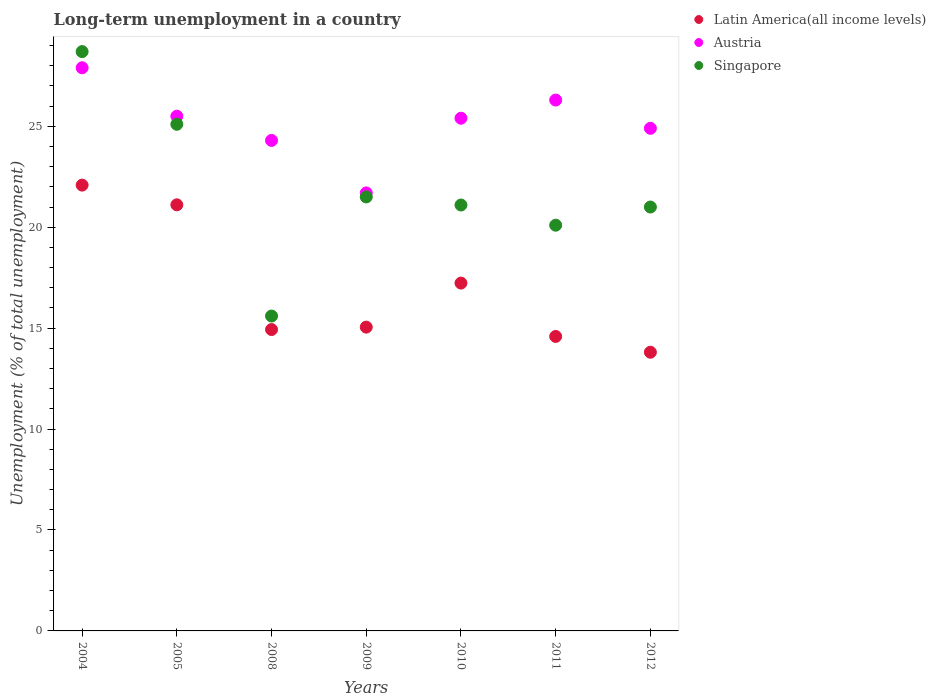How many different coloured dotlines are there?
Ensure brevity in your answer.  3. What is the percentage of long-term unemployed population in Latin America(all income levels) in 2008?
Your answer should be compact. 14.93. Across all years, what is the maximum percentage of long-term unemployed population in Austria?
Give a very brief answer. 27.9. Across all years, what is the minimum percentage of long-term unemployed population in Latin America(all income levels)?
Your response must be concise. 13.81. In which year was the percentage of long-term unemployed population in Singapore maximum?
Provide a short and direct response. 2004. In which year was the percentage of long-term unemployed population in Singapore minimum?
Your answer should be very brief. 2008. What is the total percentage of long-term unemployed population in Austria in the graph?
Your answer should be compact. 176. What is the difference between the percentage of long-term unemployed population in Singapore in 2005 and that in 2010?
Offer a terse response. 4. What is the difference between the percentage of long-term unemployed population in Singapore in 2005 and the percentage of long-term unemployed population in Latin America(all income levels) in 2010?
Give a very brief answer. 7.87. What is the average percentage of long-term unemployed population in Austria per year?
Your answer should be compact. 25.14. In the year 2012, what is the difference between the percentage of long-term unemployed population in Austria and percentage of long-term unemployed population in Singapore?
Your answer should be compact. 3.9. What is the ratio of the percentage of long-term unemployed population in Latin America(all income levels) in 2005 to that in 2008?
Your answer should be very brief. 1.41. Is the percentage of long-term unemployed population in Singapore in 2008 less than that in 2009?
Give a very brief answer. Yes. Is the difference between the percentage of long-term unemployed population in Austria in 2008 and 2010 greater than the difference between the percentage of long-term unemployed population in Singapore in 2008 and 2010?
Provide a succinct answer. Yes. What is the difference between the highest and the second highest percentage of long-term unemployed population in Latin America(all income levels)?
Provide a succinct answer. 0.98. What is the difference between the highest and the lowest percentage of long-term unemployed population in Austria?
Give a very brief answer. 6.2. Is the sum of the percentage of long-term unemployed population in Singapore in 2005 and 2012 greater than the maximum percentage of long-term unemployed population in Austria across all years?
Offer a very short reply. Yes. Is it the case that in every year, the sum of the percentage of long-term unemployed population in Singapore and percentage of long-term unemployed population in Austria  is greater than the percentage of long-term unemployed population in Latin America(all income levels)?
Your response must be concise. Yes. Does the percentage of long-term unemployed population in Latin America(all income levels) monotonically increase over the years?
Your response must be concise. No. How many dotlines are there?
Your answer should be very brief. 3. How many years are there in the graph?
Ensure brevity in your answer.  7. Are the values on the major ticks of Y-axis written in scientific E-notation?
Keep it short and to the point. No. Does the graph contain any zero values?
Offer a terse response. No. Where does the legend appear in the graph?
Your response must be concise. Top right. What is the title of the graph?
Make the answer very short. Long-term unemployment in a country. Does "Oman" appear as one of the legend labels in the graph?
Your response must be concise. No. What is the label or title of the Y-axis?
Keep it short and to the point. Unemployment (% of total unemployment). What is the Unemployment (% of total unemployment) in Latin America(all income levels) in 2004?
Provide a succinct answer. 22.09. What is the Unemployment (% of total unemployment) of Austria in 2004?
Your answer should be very brief. 27.9. What is the Unemployment (% of total unemployment) in Singapore in 2004?
Your answer should be very brief. 28.7. What is the Unemployment (% of total unemployment) of Latin America(all income levels) in 2005?
Your response must be concise. 21.11. What is the Unemployment (% of total unemployment) in Austria in 2005?
Ensure brevity in your answer.  25.5. What is the Unemployment (% of total unemployment) of Singapore in 2005?
Keep it short and to the point. 25.1. What is the Unemployment (% of total unemployment) of Latin America(all income levels) in 2008?
Make the answer very short. 14.93. What is the Unemployment (% of total unemployment) of Austria in 2008?
Give a very brief answer. 24.3. What is the Unemployment (% of total unemployment) of Singapore in 2008?
Your answer should be very brief. 15.6. What is the Unemployment (% of total unemployment) of Latin America(all income levels) in 2009?
Ensure brevity in your answer.  15.05. What is the Unemployment (% of total unemployment) in Austria in 2009?
Make the answer very short. 21.7. What is the Unemployment (% of total unemployment) in Singapore in 2009?
Provide a succinct answer. 21.5. What is the Unemployment (% of total unemployment) of Latin America(all income levels) in 2010?
Your response must be concise. 17.23. What is the Unemployment (% of total unemployment) in Austria in 2010?
Your response must be concise. 25.4. What is the Unemployment (% of total unemployment) in Singapore in 2010?
Your answer should be compact. 21.1. What is the Unemployment (% of total unemployment) of Latin America(all income levels) in 2011?
Keep it short and to the point. 14.59. What is the Unemployment (% of total unemployment) in Austria in 2011?
Provide a succinct answer. 26.3. What is the Unemployment (% of total unemployment) of Singapore in 2011?
Offer a very short reply. 20.1. What is the Unemployment (% of total unemployment) in Latin America(all income levels) in 2012?
Ensure brevity in your answer.  13.81. What is the Unemployment (% of total unemployment) in Austria in 2012?
Your answer should be very brief. 24.9. What is the Unemployment (% of total unemployment) of Singapore in 2012?
Offer a very short reply. 21. Across all years, what is the maximum Unemployment (% of total unemployment) of Latin America(all income levels)?
Keep it short and to the point. 22.09. Across all years, what is the maximum Unemployment (% of total unemployment) of Austria?
Ensure brevity in your answer.  27.9. Across all years, what is the maximum Unemployment (% of total unemployment) in Singapore?
Offer a very short reply. 28.7. Across all years, what is the minimum Unemployment (% of total unemployment) of Latin America(all income levels)?
Your answer should be compact. 13.81. Across all years, what is the minimum Unemployment (% of total unemployment) in Austria?
Offer a terse response. 21.7. Across all years, what is the minimum Unemployment (% of total unemployment) of Singapore?
Ensure brevity in your answer.  15.6. What is the total Unemployment (% of total unemployment) of Latin America(all income levels) in the graph?
Ensure brevity in your answer.  118.8. What is the total Unemployment (% of total unemployment) in Austria in the graph?
Offer a terse response. 176. What is the total Unemployment (% of total unemployment) in Singapore in the graph?
Give a very brief answer. 153.1. What is the difference between the Unemployment (% of total unemployment) of Latin America(all income levels) in 2004 and that in 2005?
Make the answer very short. 0.98. What is the difference between the Unemployment (% of total unemployment) of Austria in 2004 and that in 2005?
Provide a short and direct response. 2.4. What is the difference between the Unemployment (% of total unemployment) of Singapore in 2004 and that in 2005?
Give a very brief answer. 3.6. What is the difference between the Unemployment (% of total unemployment) in Latin America(all income levels) in 2004 and that in 2008?
Provide a succinct answer. 7.16. What is the difference between the Unemployment (% of total unemployment) in Latin America(all income levels) in 2004 and that in 2009?
Make the answer very short. 7.04. What is the difference between the Unemployment (% of total unemployment) in Austria in 2004 and that in 2009?
Your answer should be compact. 6.2. What is the difference between the Unemployment (% of total unemployment) in Singapore in 2004 and that in 2009?
Ensure brevity in your answer.  7.2. What is the difference between the Unemployment (% of total unemployment) in Latin America(all income levels) in 2004 and that in 2010?
Ensure brevity in your answer.  4.85. What is the difference between the Unemployment (% of total unemployment) of Austria in 2004 and that in 2010?
Your answer should be compact. 2.5. What is the difference between the Unemployment (% of total unemployment) of Singapore in 2004 and that in 2010?
Ensure brevity in your answer.  7.6. What is the difference between the Unemployment (% of total unemployment) in Latin America(all income levels) in 2004 and that in 2011?
Offer a very short reply. 7.5. What is the difference between the Unemployment (% of total unemployment) of Latin America(all income levels) in 2004 and that in 2012?
Offer a terse response. 8.28. What is the difference between the Unemployment (% of total unemployment) of Singapore in 2004 and that in 2012?
Make the answer very short. 7.7. What is the difference between the Unemployment (% of total unemployment) of Latin America(all income levels) in 2005 and that in 2008?
Your response must be concise. 6.18. What is the difference between the Unemployment (% of total unemployment) in Austria in 2005 and that in 2008?
Your answer should be very brief. 1.2. What is the difference between the Unemployment (% of total unemployment) in Latin America(all income levels) in 2005 and that in 2009?
Make the answer very short. 6.06. What is the difference between the Unemployment (% of total unemployment) in Singapore in 2005 and that in 2009?
Your response must be concise. 3.6. What is the difference between the Unemployment (% of total unemployment) in Latin America(all income levels) in 2005 and that in 2010?
Your answer should be compact. 3.88. What is the difference between the Unemployment (% of total unemployment) of Singapore in 2005 and that in 2010?
Your response must be concise. 4. What is the difference between the Unemployment (% of total unemployment) in Latin America(all income levels) in 2005 and that in 2011?
Make the answer very short. 6.52. What is the difference between the Unemployment (% of total unemployment) of Austria in 2005 and that in 2011?
Your answer should be compact. -0.8. What is the difference between the Unemployment (% of total unemployment) in Latin America(all income levels) in 2005 and that in 2012?
Your answer should be compact. 7.3. What is the difference between the Unemployment (% of total unemployment) in Austria in 2005 and that in 2012?
Your answer should be compact. 0.6. What is the difference between the Unemployment (% of total unemployment) in Singapore in 2005 and that in 2012?
Provide a succinct answer. 4.1. What is the difference between the Unemployment (% of total unemployment) of Latin America(all income levels) in 2008 and that in 2009?
Keep it short and to the point. -0.12. What is the difference between the Unemployment (% of total unemployment) in Singapore in 2008 and that in 2009?
Make the answer very short. -5.9. What is the difference between the Unemployment (% of total unemployment) in Latin America(all income levels) in 2008 and that in 2010?
Provide a short and direct response. -2.3. What is the difference between the Unemployment (% of total unemployment) of Austria in 2008 and that in 2010?
Your response must be concise. -1.1. What is the difference between the Unemployment (% of total unemployment) of Latin America(all income levels) in 2008 and that in 2011?
Your answer should be compact. 0.34. What is the difference between the Unemployment (% of total unemployment) in Austria in 2008 and that in 2011?
Provide a short and direct response. -2. What is the difference between the Unemployment (% of total unemployment) in Latin America(all income levels) in 2008 and that in 2012?
Your answer should be compact. 1.12. What is the difference between the Unemployment (% of total unemployment) of Austria in 2008 and that in 2012?
Your response must be concise. -0.6. What is the difference between the Unemployment (% of total unemployment) of Singapore in 2008 and that in 2012?
Make the answer very short. -5.4. What is the difference between the Unemployment (% of total unemployment) in Latin America(all income levels) in 2009 and that in 2010?
Provide a short and direct response. -2.18. What is the difference between the Unemployment (% of total unemployment) of Austria in 2009 and that in 2010?
Ensure brevity in your answer.  -3.7. What is the difference between the Unemployment (% of total unemployment) of Latin America(all income levels) in 2009 and that in 2011?
Ensure brevity in your answer.  0.46. What is the difference between the Unemployment (% of total unemployment) of Latin America(all income levels) in 2009 and that in 2012?
Give a very brief answer. 1.24. What is the difference between the Unemployment (% of total unemployment) in Singapore in 2009 and that in 2012?
Your answer should be very brief. 0.5. What is the difference between the Unemployment (% of total unemployment) of Latin America(all income levels) in 2010 and that in 2011?
Give a very brief answer. 2.64. What is the difference between the Unemployment (% of total unemployment) in Singapore in 2010 and that in 2011?
Offer a terse response. 1. What is the difference between the Unemployment (% of total unemployment) in Latin America(all income levels) in 2010 and that in 2012?
Make the answer very short. 3.43. What is the difference between the Unemployment (% of total unemployment) in Latin America(all income levels) in 2011 and that in 2012?
Keep it short and to the point. 0.78. What is the difference between the Unemployment (% of total unemployment) of Latin America(all income levels) in 2004 and the Unemployment (% of total unemployment) of Austria in 2005?
Offer a terse response. -3.41. What is the difference between the Unemployment (% of total unemployment) of Latin America(all income levels) in 2004 and the Unemployment (% of total unemployment) of Singapore in 2005?
Keep it short and to the point. -3.01. What is the difference between the Unemployment (% of total unemployment) in Austria in 2004 and the Unemployment (% of total unemployment) in Singapore in 2005?
Provide a short and direct response. 2.8. What is the difference between the Unemployment (% of total unemployment) in Latin America(all income levels) in 2004 and the Unemployment (% of total unemployment) in Austria in 2008?
Offer a terse response. -2.21. What is the difference between the Unemployment (% of total unemployment) of Latin America(all income levels) in 2004 and the Unemployment (% of total unemployment) of Singapore in 2008?
Offer a terse response. 6.49. What is the difference between the Unemployment (% of total unemployment) of Latin America(all income levels) in 2004 and the Unemployment (% of total unemployment) of Austria in 2009?
Your answer should be compact. 0.39. What is the difference between the Unemployment (% of total unemployment) of Latin America(all income levels) in 2004 and the Unemployment (% of total unemployment) of Singapore in 2009?
Your answer should be very brief. 0.59. What is the difference between the Unemployment (% of total unemployment) of Austria in 2004 and the Unemployment (% of total unemployment) of Singapore in 2009?
Your answer should be compact. 6.4. What is the difference between the Unemployment (% of total unemployment) of Latin America(all income levels) in 2004 and the Unemployment (% of total unemployment) of Austria in 2010?
Your answer should be compact. -3.31. What is the difference between the Unemployment (% of total unemployment) in Latin America(all income levels) in 2004 and the Unemployment (% of total unemployment) in Singapore in 2010?
Make the answer very short. 0.99. What is the difference between the Unemployment (% of total unemployment) in Austria in 2004 and the Unemployment (% of total unemployment) in Singapore in 2010?
Give a very brief answer. 6.8. What is the difference between the Unemployment (% of total unemployment) in Latin America(all income levels) in 2004 and the Unemployment (% of total unemployment) in Austria in 2011?
Ensure brevity in your answer.  -4.21. What is the difference between the Unemployment (% of total unemployment) of Latin America(all income levels) in 2004 and the Unemployment (% of total unemployment) of Singapore in 2011?
Your response must be concise. 1.99. What is the difference between the Unemployment (% of total unemployment) in Austria in 2004 and the Unemployment (% of total unemployment) in Singapore in 2011?
Offer a very short reply. 7.8. What is the difference between the Unemployment (% of total unemployment) in Latin America(all income levels) in 2004 and the Unemployment (% of total unemployment) in Austria in 2012?
Keep it short and to the point. -2.81. What is the difference between the Unemployment (% of total unemployment) in Latin America(all income levels) in 2004 and the Unemployment (% of total unemployment) in Singapore in 2012?
Keep it short and to the point. 1.09. What is the difference between the Unemployment (% of total unemployment) of Latin America(all income levels) in 2005 and the Unemployment (% of total unemployment) of Austria in 2008?
Keep it short and to the point. -3.19. What is the difference between the Unemployment (% of total unemployment) in Latin America(all income levels) in 2005 and the Unemployment (% of total unemployment) in Singapore in 2008?
Your response must be concise. 5.51. What is the difference between the Unemployment (% of total unemployment) in Latin America(all income levels) in 2005 and the Unemployment (% of total unemployment) in Austria in 2009?
Keep it short and to the point. -0.59. What is the difference between the Unemployment (% of total unemployment) in Latin America(all income levels) in 2005 and the Unemployment (% of total unemployment) in Singapore in 2009?
Provide a succinct answer. -0.39. What is the difference between the Unemployment (% of total unemployment) in Austria in 2005 and the Unemployment (% of total unemployment) in Singapore in 2009?
Give a very brief answer. 4. What is the difference between the Unemployment (% of total unemployment) in Latin America(all income levels) in 2005 and the Unemployment (% of total unemployment) in Austria in 2010?
Provide a succinct answer. -4.29. What is the difference between the Unemployment (% of total unemployment) in Latin America(all income levels) in 2005 and the Unemployment (% of total unemployment) in Singapore in 2010?
Keep it short and to the point. 0.01. What is the difference between the Unemployment (% of total unemployment) of Austria in 2005 and the Unemployment (% of total unemployment) of Singapore in 2010?
Your response must be concise. 4.4. What is the difference between the Unemployment (% of total unemployment) of Latin America(all income levels) in 2005 and the Unemployment (% of total unemployment) of Austria in 2011?
Give a very brief answer. -5.19. What is the difference between the Unemployment (% of total unemployment) in Latin America(all income levels) in 2005 and the Unemployment (% of total unemployment) in Singapore in 2011?
Offer a terse response. 1.01. What is the difference between the Unemployment (% of total unemployment) of Latin America(all income levels) in 2005 and the Unemployment (% of total unemployment) of Austria in 2012?
Your answer should be very brief. -3.79. What is the difference between the Unemployment (% of total unemployment) in Latin America(all income levels) in 2005 and the Unemployment (% of total unemployment) in Singapore in 2012?
Offer a very short reply. 0.11. What is the difference between the Unemployment (% of total unemployment) of Latin America(all income levels) in 2008 and the Unemployment (% of total unemployment) of Austria in 2009?
Your response must be concise. -6.77. What is the difference between the Unemployment (% of total unemployment) of Latin America(all income levels) in 2008 and the Unemployment (% of total unemployment) of Singapore in 2009?
Your response must be concise. -6.57. What is the difference between the Unemployment (% of total unemployment) in Latin America(all income levels) in 2008 and the Unemployment (% of total unemployment) in Austria in 2010?
Provide a short and direct response. -10.47. What is the difference between the Unemployment (% of total unemployment) in Latin America(all income levels) in 2008 and the Unemployment (% of total unemployment) in Singapore in 2010?
Make the answer very short. -6.17. What is the difference between the Unemployment (% of total unemployment) of Latin America(all income levels) in 2008 and the Unemployment (% of total unemployment) of Austria in 2011?
Offer a very short reply. -11.37. What is the difference between the Unemployment (% of total unemployment) in Latin America(all income levels) in 2008 and the Unemployment (% of total unemployment) in Singapore in 2011?
Keep it short and to the point. -5.17. What is the difference between the Unemployment (% of total unemployment) of Latin America(all income levels) in 2008 and the Unemployment (% of total unemployment) of Austria in 2012?
Your answer should be very brief. -9.97. What is the difference between the Unemployment (% of total unemployment) of Latin America(all income levels) in 2008 and the Unemployment (% of total unemployment) of Singapore in 2012?
Your response must be concise. -6.07. What is the difference between the Unemployment (% of total unemployment) of Austria in 2008 and the Unemployment (% of total unemployment) of Singapore in 2012?
Your response must be concise. 3.3. What is the difference between the Unemployment (% of total unemployment) in Latin America(all income levels) in 2009 and the Unemployment (% of total unemployment) in Austria in 2010?
Ensure brevity in your answer.  -10.35. What is the difference between the Unemployment (% of total unemployment) in Latin America(all income levels) in 2009 and the Unemployment (% of total unemployment) in Singapore in 2010?
Your answer should be very brief. -6.05. What is the difference between the Unemployment (% of total unemployment) of Latin America(all income levels) in 2009 and the Unemployment (% of total unemployment) of Austria in 2011?
Give a very brief answer. -11.25. What is the difference between the Unemployment (% of total unemployment) of Latin America(all income levels) in 2009 and the Unemployment (% of total unemployment) of Singapore in 2011?
Offer a very short reply. -5.05. What is the difference between the Unemployment (% of total unemployment) in Latin America(all income levels) in 2009 and the Unemployment (% of total unemployment) in Austria in 2012?
Offer a terse response. -9.85. What is the difference between the Unemployment (% of total unemployment) of Latin America(all income levels) in 2009 and the Unemployment (% of total unemployment) of Singapore in 2012?
Your response must be concise. -5.95. What is the difference between the Unemployment (% of total unemployment) in Latin America(all income levels) in 2010 and the Unemployment (% of total unemployment) in Austria in 2011?
Keep it short and to the point. -9.07. What is the difference between the Unemployment (% of total unemployment) in Latin America(all income levels) in 2010 and the Unemployment (% of total unemployment) in Singapore in 2011?
Offer a terse response. -2.87. What is the difference between the Unemployment (% of total unemployment) in Latin America(all income levels) in 2010 and the Unemployment (% of total unemployment) in Austria in 2012?
Provide a succinct answer. -7.67. What is the difference between the Unemployment (% of total unemployment) in Latin America(all income levels) in 2010 and the Unemployment (% of total unemployment) in Singapore in 2012?
Keep it short and to the point. -3.77. What is the difference between the Unemployment (% of total unemployment) in Austria in 2010 and the Unemployment (% of total unemployment) in Singapore in 2012?
Your answer should be compact. 4.4. What is the difference between the Unemployment (% of total unemployment) of Latin America(all income levels) in 2011 and the Unemployment (% of total unemployment) of Austria in 2012?
Your answer should be compact. -10.31. What is the difference between the Unemployment (% of total unemployment) of Latin America(all income levels) in 2011 and the Unemployment (% of total unemployment) of Singapore in 2012?
Your response must be concise. -6.41. What is the difference between the Unemployment (% of total unemployment) of Austria in 2011 and the Unemployment (% of total unemployment) of Singapore in 2012?
Offer a terse response. 5.3. What is the average Unemployment (% of total unemployment) of Latin America(all income levels) per year?
Keep it short and to the point. 16.97. What is the average Unemployment (% of total unemployment) of Austria per year?
Your response must be concise. 25.14. What is the average Unemployment (% of total unemployment) of Singapore per year?
Provide a short and direct response. 21.87. In the year 2004, what is the difference between the Unemployment (% of total unemployment) of Latin America(all income levels) and Unemployment (% of total unemployment) of Austria?
Provide a succinct answer. -5.81. In the year 2004, what is the difference between the Unemployment (% of total unemployment) of Latin America(all income levels) and Unemployment (% of total unemployment) of Singapore?
Offer a terse response. -6.61. In the year 2005, what is the difference between the Unemployment (% of total unemployment) of Latin America(all income levels) and Unemployment (% of total unemployment) of Austria?
Make the answer very short. -4.39. In the year 2005, what is the difference between the Unemployment (% of total unemployment) in Latin America(all income levels) and Unemployment (% of total unemployment) in Singapore?
Give a very brief answer. -3.99. In the year 2005, what is the difference between the Unemployment (% of total unemployment) in Austria and Unemployment (% of total unemployment) in Singapore?
Ensure brevity in your answer.  0.4. In the year 2008, what is the difference between the Unemployment (% of total unemployment) of Latin America(all income levels) and Unemployment (% of total unemployment) of Austria?
Provide a succinct answer. -9.37. In the year 2008, what is the difference between the Unemployment (% of total unemployment) of Latin America(all income levels) and Unemployment (% of total unemployment) of Singapore?
Keep it short and to the point. -0.67. In the year 2009, what is the difference between the Unemployment (% of total unemployment) in Latin America(all income levels) and Unemployment (% of total unemployment) in Austria?
Offer a very short reply. -6.65. In the year 2009, what is the difference between the Unemployment (% of total unemployment) of Latin America(all income levels) and Unemployment (% of total unemployment) of Singapore?
Provide a succinct answer. -6.45. In the year 2010, what is the difference between the Unemployment (% of total unemployment) in Latin America(all income levels) and Unemployment (% of total unemployment) in Austria?
Give a very brief answer. -8.17. In the year 2010, what is the difference between the Unemployment (% of total unemployment) of Latin America(all income levels) and Unemployment (% of total unemployment) of Singapore?
Offer a terse response. -3.87. In the year 2010, what is the difference between the Unemployment (% of total unemployment) of Austria and Unemployment (% of total unemployment) of Singapore?
Give a very brief answer. 4.3. In the year 2011, what is the difference between the Unemployment (% of total unemployment) in Latin America(all income levels) and Unemployment (% of total unemployment) in Austria?
Your answer should be very brief. -11.71. In the year 2011, what is the difference between the Unemployment (% of total unemployment) in Latin America(all income levels) and Unemployment (% of total unemployment) in Singapore?
Provide a succinct answer. -5.51. In the year 2011, what is the difference between the Unemployment (% of total unemployment) in Austria and Unemployment (% of total unemployment) in Singapore?
Offer a very short reply. 6.2. In the year 2012, what is the difference between the Unemployment (% of total unemployment) of Latin America(all income levels) and Unemployment (% of total unemployment) of Austria?
Offer a terse response. -11.09. In the year 2012, what is the difference between the Unemployment (% of total unemployment) in Latin America(all income levels) and Unemployment (% of total unemployment) in Singapore?
Offer a terse response. -7.19. What is the ratio of the Unemployment (% of total unemployment) of Latin America(all income levels) in 2004 to that in 2005?
Make the answer very short. 1.05. What is the ratio of the Unemployment (% of total unemployment) in Austria in 2004 to that in 2005?
Your response must be concise. 1.09. What is the ratio of the Unemployment (% of total unemployment) of Singapore in 2004 to that in 2005?
Your response must be concise. 1.14. What is the ratio of the Unemployment (% of total unemployment) in Latin America(all income levels) in 2004 to that in 2008?
Provide a succinct answer. 1.48. What is the ratio of the Unemployment (% of total unemployment) in Austria in 2004 to that in 2008?
Your response must be concise. 1.15. What is the ratio of the Unemployment (% of total unemployment) in Singapore in 2004 to that in 2008?
Your response must be concise. 1.84. What is the ratio of the Unemployment (% of total unemployment) of Latin America(all income levels) in 2004 to that in 2009?
Offer a very short reply. 1.47. What is the ratio of the Unemployment (% of total unemployment) of Singapore in 2004 to that in 2009?
Provide a succinct answer. 1.33. What is the ratio of the Unemployment (% of total unemployment) of Latin America(all income levels) in 2004 to that in 2010?
Give a very brief answer. 1.28. What is the ratio of the Unemployment (% of total unemployment) of Austria in 2004 to that in 2010?
Make the answer very short. 1.1. What is the ratio of the Unemployment (% of total unemployment) in Singapore in 2004 to that in 2010?
Your answer should be very brief. 1.36. What is the ratio of the Unemployment (% of total unemployment) of Latin America(all income levels) in 2004 to that in 2011?
Your response must be concise. 1.51. What is the ratio of the Unemployment (% of total unemployment) in Austria in 2004 to that in 2011?
Provide a short and direct response. 1.06. What is the ratio of the Unemployment (% of total unemployment) of Singapore in 2004 to that in 2011?
Your answer should be very brief. 1.43. What is the ratio of the Unemployment (% of total unemployment) of Latin America(all income levels) in 2004 to that in 2012?
Your answer should be compact. 1.6. What is the ratio of the Unemployment (% of total unemployment) of Austria in 2004 to that in 2012?
Provide a short and direct response. 1.12. What is the ratio of the Unemployment (% of total unemployment) of Singapore in 2004 to that in 2012?
Your response must be concise. 1.37. What is the ratio of the Unemployment (% of total unemployment) in Latin America(all income levels) in 2005 to that in 2008?
Your answer should be very brief. 1.41. What is the ratio of the Unemployment (% of total unemployment) in Austria in 2005 to that in 2008?
Keep it short and to the point. 1.05. What is the ratio of the Unemployment (% of total unemployment) of Singapore in 2005 to that in 2008?
Offer a very short reply. 1.61. What is the ratio of the Unemployment (% of total unemployment) in Latin America(all income levels) in 2005 to that in 2009?
Offer a very short reply. 1.4. What is the ratio of the Unemployment (% of total unemployment) in Austria in 2005 to that in 2009?
Your response must be concise. 1.18. What is the ratio of the Unemployment (% of total unemployment) in Singapore in 2005 to that in 2009?
Your answer should be compact. 1.17. What is the ratio of the Unemployment (% of total unemployment) in Latin America(all income levels) in 2005 to that in 2010?
Give a very brief answer. 1.23. What is the ratio of the Unemployment (% of total unemployment) in Singapore in 2005 to that in 2010?
Give a very brief answer. 1.19. What is the ratio of the Unemployment (% of total unemployment) of Latin America(all income levels) in 2005 to that in 2011?
Provide a short and direct response. 1.45. What is the ratio of the Unemployment (% of total unemployment) of Austria in 2005 to that in 2011?
Offer a terse response. 0.97. What is the ratio of the Unemployment (% of total unemployment) of Singapore in 2005 to that in 2011?
Make the answer very short. 1.25. What is the ratio of the Unemployment (% of total unemployment) of Latin America(all income levels) in 2005 to that in 2012?
Your response must be concise. 1.53. What is the ratio of the Unemployment (% of total unemployment) of Austria in 2005 to that in 2012?
Ensure brevity in your answer.  1.02. What is the ratio of the Unemployment (% of total unemployment) of Singapore in 2005 to that in 2012?
Provide a short and direct response. 1.2. What is the ratio of the Unemployment (% of total unemployment) of Austria in 2008 to that in 2009?
Make the answer very short. 1.12. What is the ratio of the Unemployment (% of total unemployment) in Singapore in 2008 to that in 2009?
Your answer should be very brief. 0.73. What is the ratio of the Unemployment (% of total unemployment) in Latin America(all income levels) in 2008 to that in 2010?
Make the answer very short. 0.87. What is the ratio of the Unemployment (% of total unemployment) in Austria in 2008 to that in 2010?
Offer a very short reply. 0.96. What is the ratio of the Unemployment (% of total unemployment) in Singapore in 2008 to that in 2010?
Your response must be concise. 0.74. What is the ratio of the Unemployment (% of total unemployment) of Latin America(all income levels) in 2008 to that in 2011?
Your answer should be very brief. 1.02. What is the ratio of the Unemployment (% of total unemployment) in Austria in 2008 to that in 2011?
Offer a very short reply. 0.92. What is the ratio of the Unemployment (% of total unemployment) of Singapore in 2008 to that in 2011?
Offer a very short reply. 0.78. What is the ratio of the Unemployment (% of total unemployment) in Latin America(all income levels) in 2008 to that in 2012?
Provide a succinct answer. 1.08. What is the ratio of the Unemployment (% of total unemployment) in Austria in 2008 to that in 2012?
Offer a terse response. 0.98. What is the ratio of the Unemployment (% of total unemployment) in Singapore in 2008 to that in 2012?
Ensure brevity in your answer.  0.74. What is the ratio of the Unemployment (% of total unemployment) of Latin America(all income levels) in 2009 to that in 2010?
Keep it short and to the point. 0.87. What is the ratio of the Unemployment (% of total unemployment) of Austria in 2009 to that in 2010?
Your answer should be compact. 0.85. What is the ratio of the Unemployment (% of total unemployment) of Latin America(all income levels) in 2009 to that in 2011?
Your answer should be very brief. 1.03. What is the ratio of the Unemployment (% of total unemployment) in Austria in 2009 to that in 2011?
Keep it short and to the point. 0.83. What is the ratio of the Unemployment (% of total unemployment) in Singapore in 2009 to that in 2011?
Keep it short and to the point. 1.07. What is the ratio of the Unemployment (% of total unemployment) of Latin America(all income levels) in 2009 to that in 2012?
Keep it short and to the point. 1.09. What is the ratio of the Unemployment (% of total unemployment) of Austria in 2009 to that in 2012?
Provide a succinct answer. 0.87. What is the ratio of the Unemployment (% of total unemployment) of Singapore in 2009 to that in 2012?
Keep it short and to the point. 1.02. What is the ratio of the Unemployment (% of total unemployment) in Latin America(all income levels) in 2010 to that in 2011?
Your answer should be very brief. 1.18. What is the ratio of the Unemployment (% of total unemployment) in Austria in 2010 to that in 2011?
Make the answer very short. 0.97. What is the ratio of the Unemployment (% of total unemployment) in Singapore in 2010 to that in 2011?
Offer a terse response. 1.05. What is the ratio of the Unemployment (% of total unemployment) in Latin America(all income levels) in 2010 to that in 2012?
Your answer should be compact. 1.25. What is the ratio of the Unemployment (% of total unemployment) in Austria in 2010 to that in 2012?
Provide a short and direct response. 1.02. What is the ratio of the Unemployment (% of total unemployment) in Singapore in 2010 to that in 2012?
Provide a short and direct response. 1. What is the ratio of the Unemployment (% of total unemployment) in Latin America(all income levels) in 2011 to that in 2012?
Offer a terse response. 1.06. What is the ratio of the Unemployment (% of total unemployment) of Austria in 2011 to that in 2012?
Offer a terse response. 1.06. What is the ratio of the Unemployment (% of total unemployment) in Singapore in 2011 to that in 2012?
Provide a succinct answer. 0.96. What is the difference between the highest and the second highest Unemployment (% of total unemployment) in Latin America(all income levels)?
Your answer should be very brief. 0.98. What is the difference between the highest and the second highest Unemployment (% of total unemployment) in Austria?
Offer a terse response. 1.6. What is the difference between the highest and the second highest Unemployment (% of total unemployment) in Singapore?
Provide a short and direct response. 3.6. What is the difference between the highest and the lowest Unemployment (% of total unemployment) in Latin America(all income levels)?
Your answer should be very brief. 8.28. What is the difference between the highest and the lowest Unemployment (% of total unemployment) in Singapore?
Make the answer very short. 13.1. 